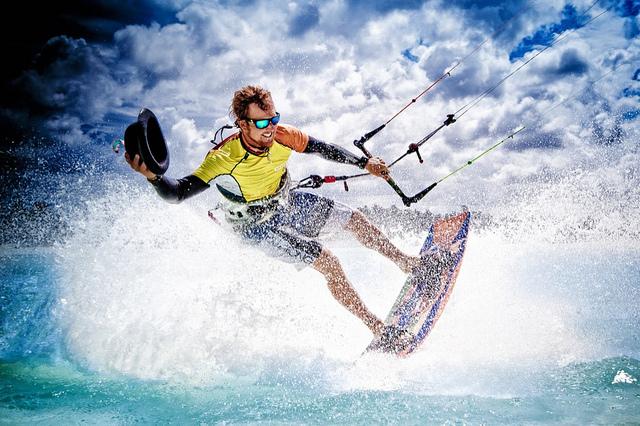What is the man holding in his right hand?
Keep it brief. Hat. Is this what a normal surfer wears?
Answer briefly. Yes. Is there a shark in the picture?
Quick response, please. No. Is the H20 above or below this man?
Be succinct. Below. 